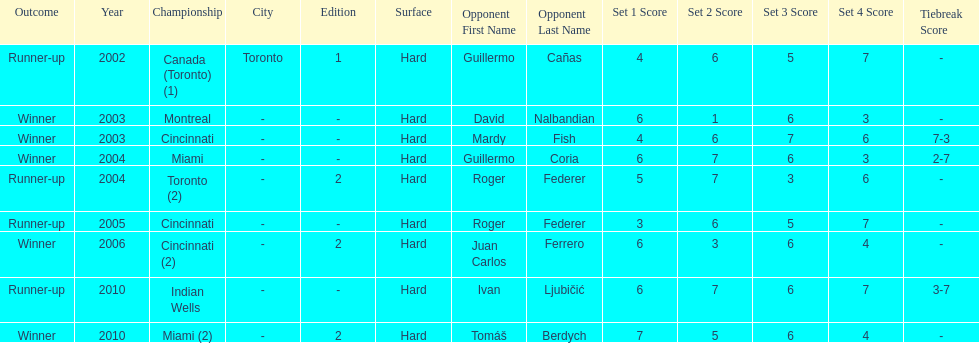What was the highest number of consecutive wins? 3. Can you give me this table as a dict? {'header': ['Outcome', 'Year', 'Championship', 'City', 'Edition', 'Surface', 'Opponent First Name', 'Opponent Last Name', 'Set 1 Score', 'Set 2 Score', 'Set 3 Score', 'Set 4 Score', 'Tiebreak Score'], 'rows': [['Runner-up', '2002', 'Canada (Toronto) (1)', 'Toronto', '1', 'Hard', 'Guillermo', 'Cañas', '4', '6', '5', '7', '-'], ['Winner', '2003', 'Montreal', '-', '-', 'Hard', 'David', 'Nalbandian', '6', '1', '6', '3', '-'], ['Winner', '2003', 'Cincinnati', '-', '-', 'Hard', 'Mardy', 'Fish', '4', '6', '7', '6', '7-3'], ['Winner', '2004', 'Miami', '-', '-', 'Hard', 'Guillermo', 'Coria', '6', '7', '6', '3', '2-7'], ['Runner-up', '2004', 'Toronto (2)', '-', '2', 'Hard', 'Roger', 'Federer', '5', '7', '3', '6', '-'], ['Runner-up', '2005', 'Cincinnati', '-', '-', 'Hard', 'Roger', 'Federer', '3', '6', '5', '7', '-'], ['Winner', '2006', 'Cincinnati (2)', '-', '2', 'Hard', 'Juan Carlos', 'Ferrero', '6', '3', '6', '4', '-'], ['Runner-up', '2010', 'Indian Wells', '-', '-', 'Hard', 'Ivan', 'Ljubičić', '6', '7', '6', '7', '3-7'], ['Winner', '2010', 'Miami (2)', '-', '2', 'Hard', 'Tomáš', 'Berdych', '7', '5', '6', '4', '-']]} 